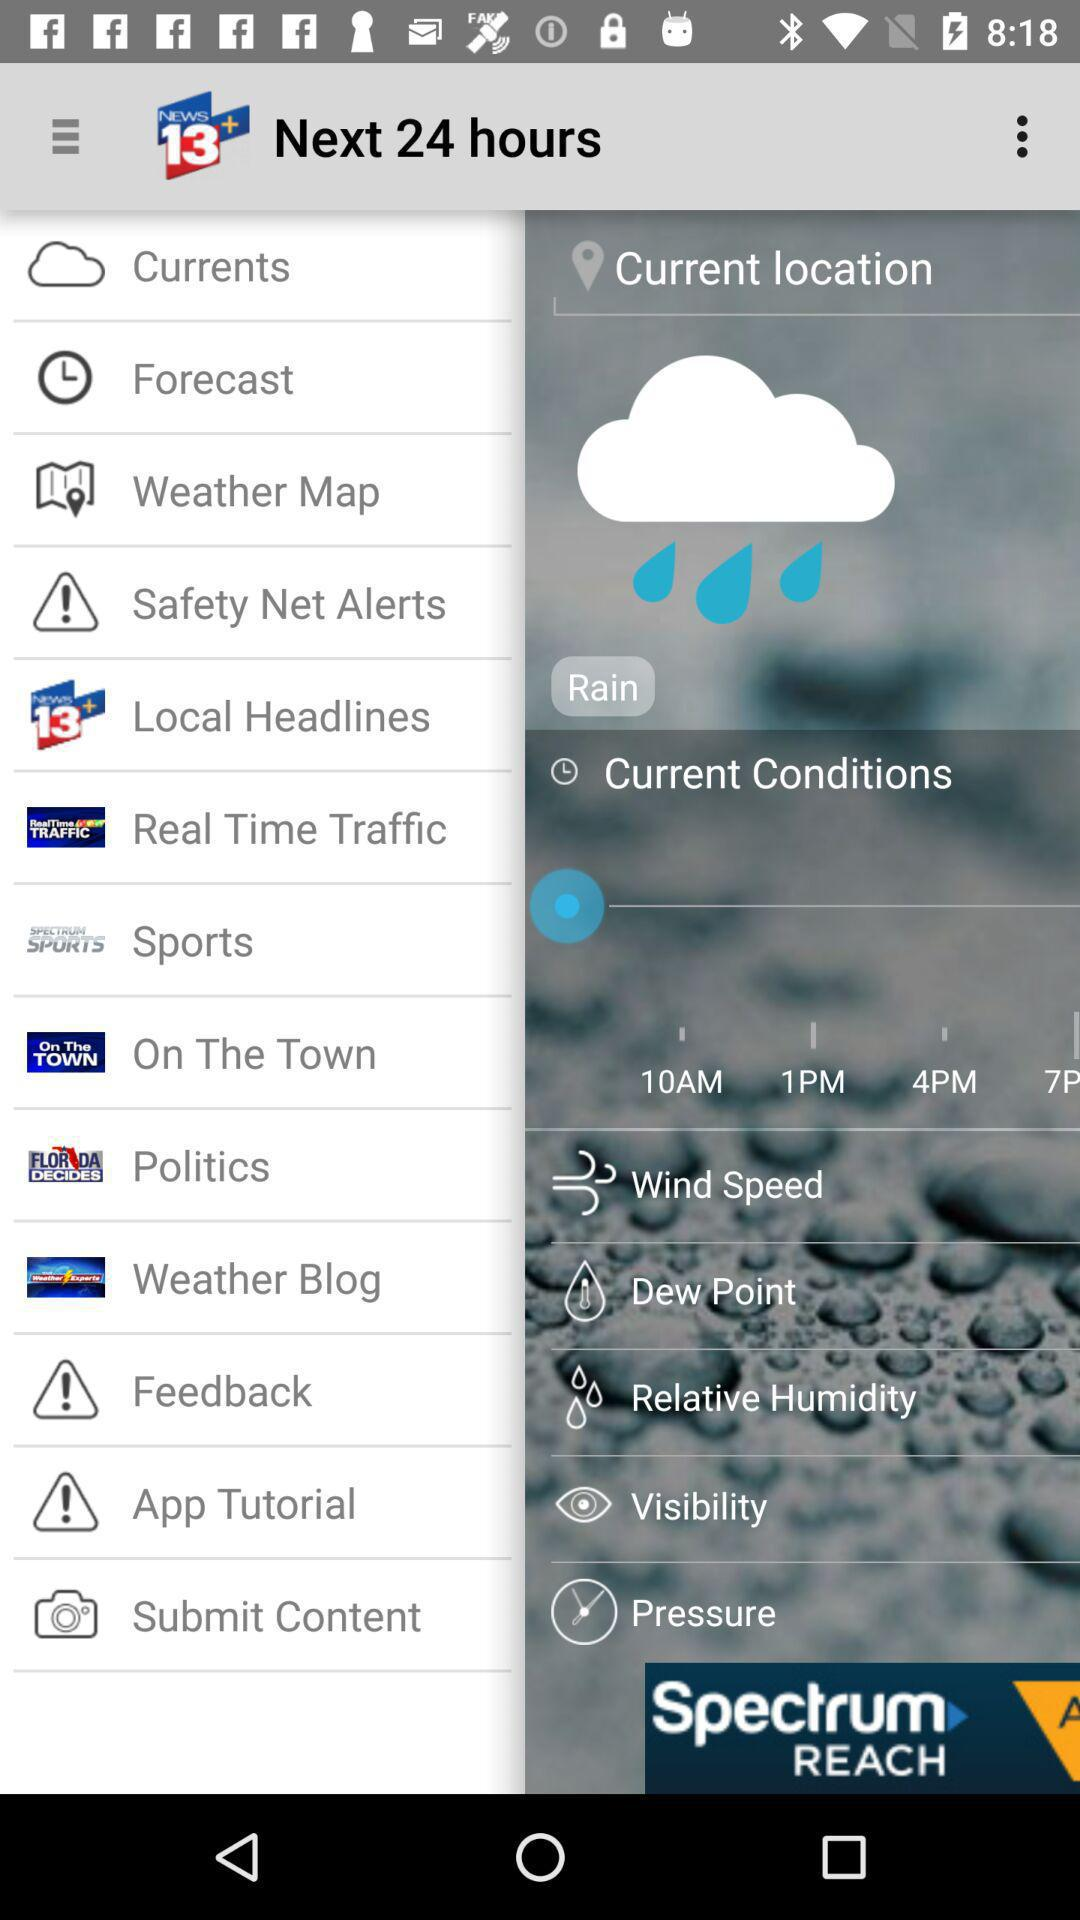What is the news channel's name? The news channel name is "NEWS 13+". 